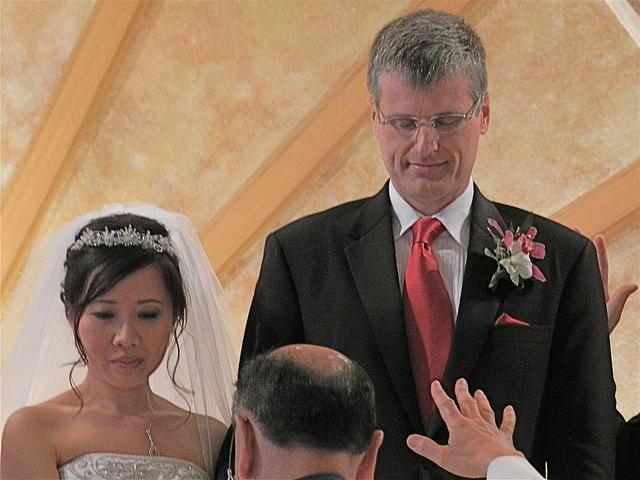Are these two related?
Write a very short answer. No. What is pinned on the man's shoulder?
Concise answer only. Flowers. What holiday is associated with the headband the girl is wearing?
Write a very short answer. Wedding. How does the bride look?
Short answer required. Sad. How many people are wearing glasses?
Write a very short answer. 1. Is the bride taller than the groom?
Concise answer only. No. What is the thing called on the females head?
Keep it brief. Veil. 